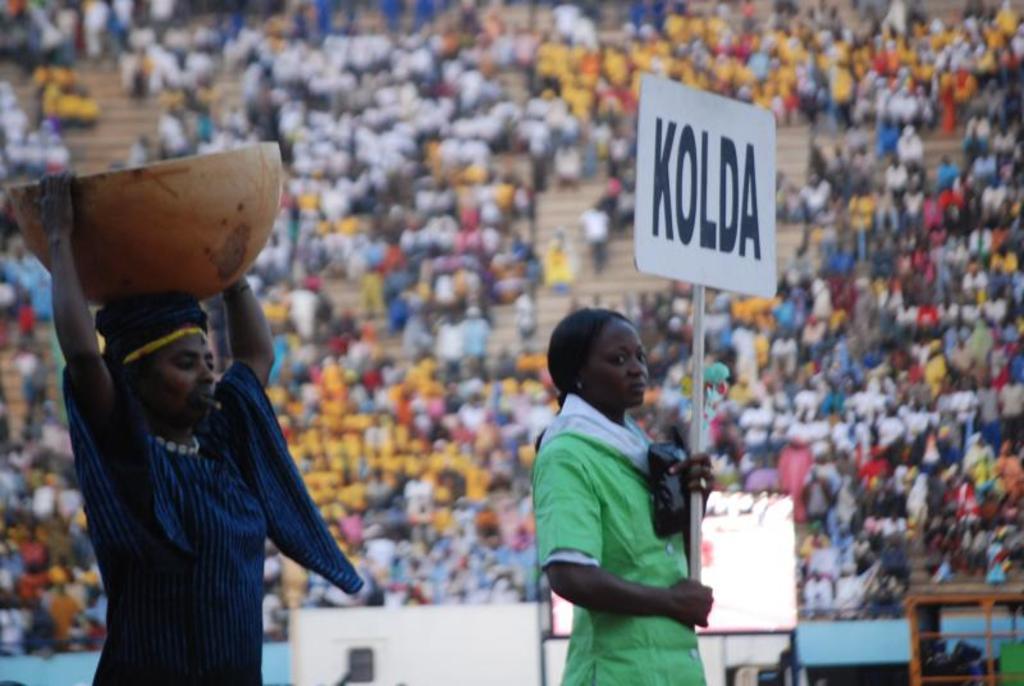Could you give a brief overview of what you see in this image? In this image a person and a woman among them the woman on the right side is holding a placard in hands and the person on the left side is holding an object in hands. In the background I can see people, boards and other objects. The background of the image is blurred. 